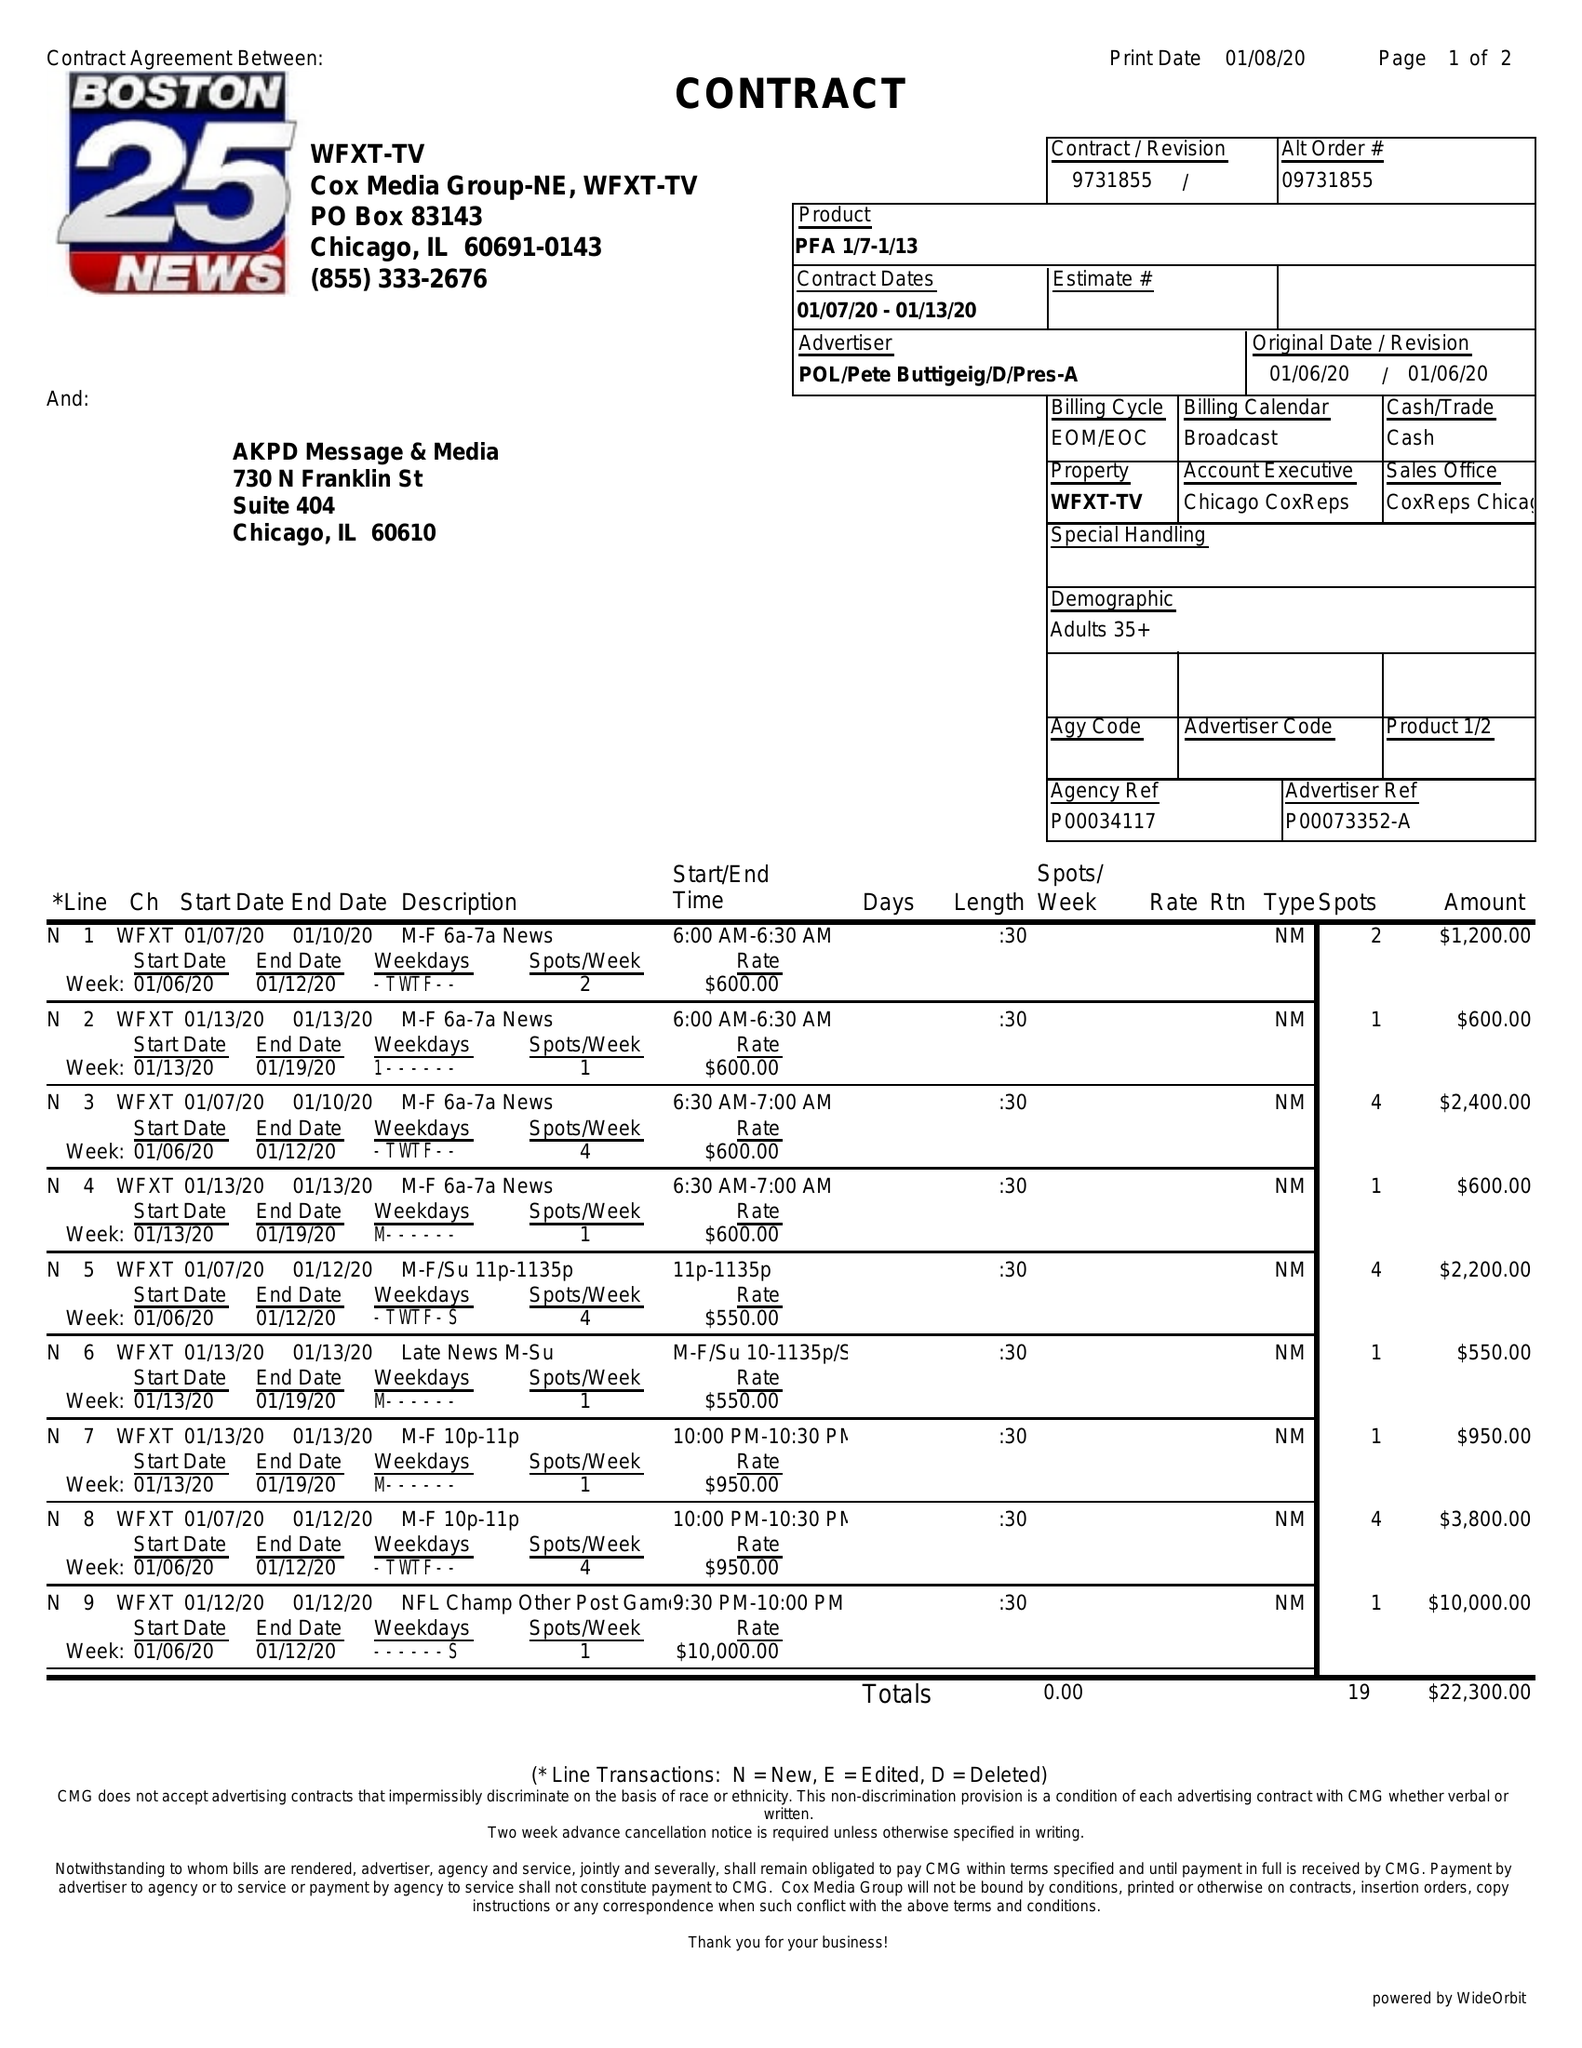What is the value for the flight_from?
Answer the question using a single word or phrase. 01/07/20 